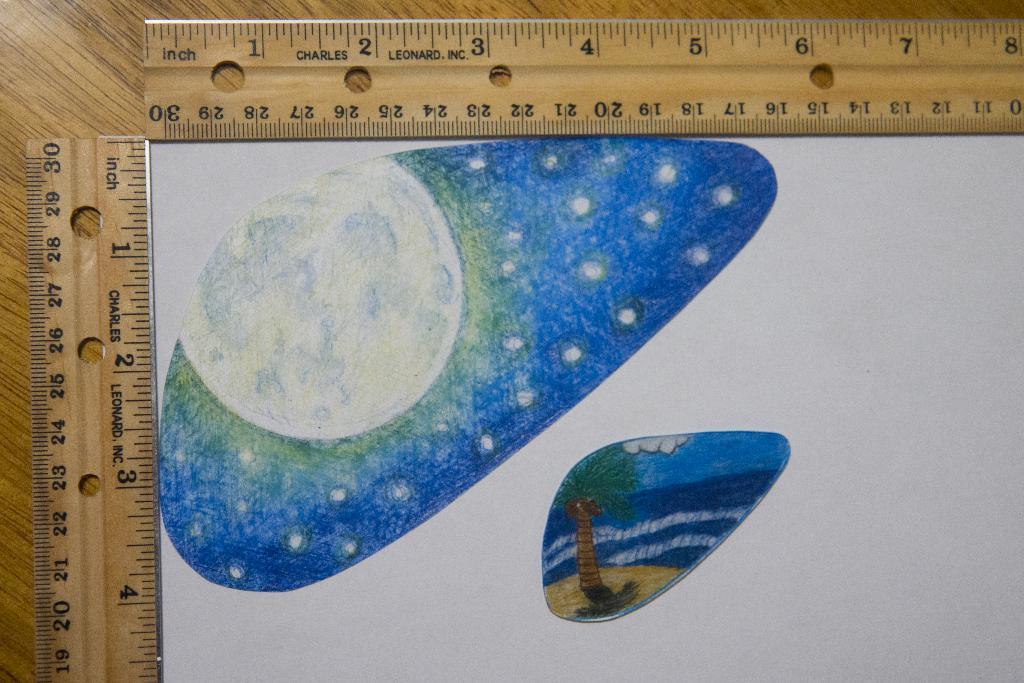Can you describe this image briefly? In this image there is a table, on that table there are two scales and a paper, on that paper there is an art. 